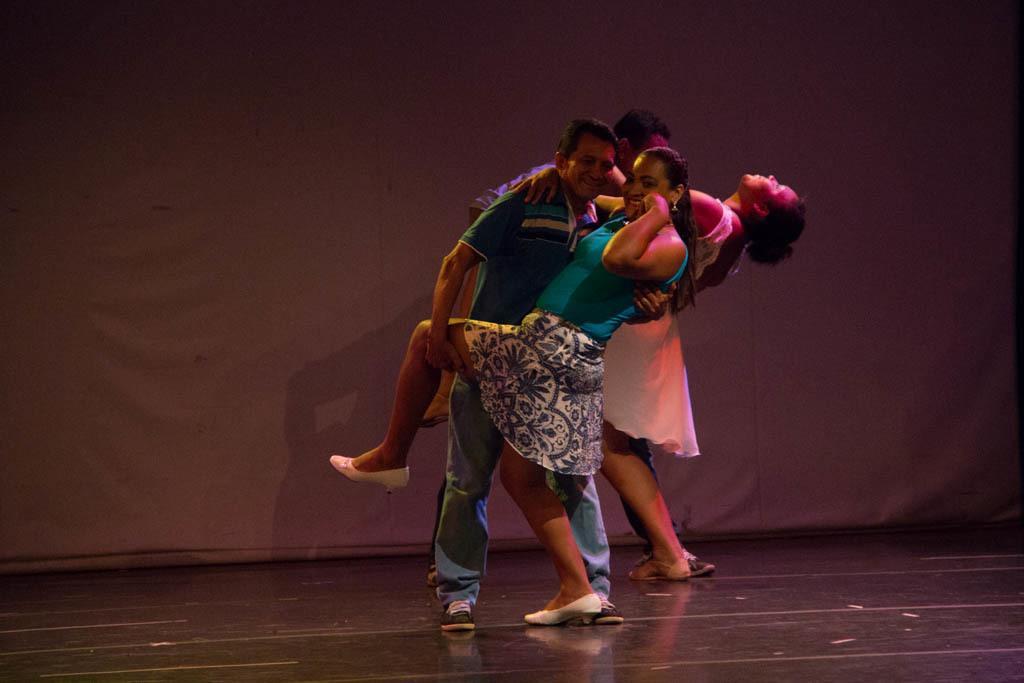In one or two sentences, can you explain what this image depicts? In this picture there are persons dancing and smiling. In the background there is a curtain which is white in colour. 